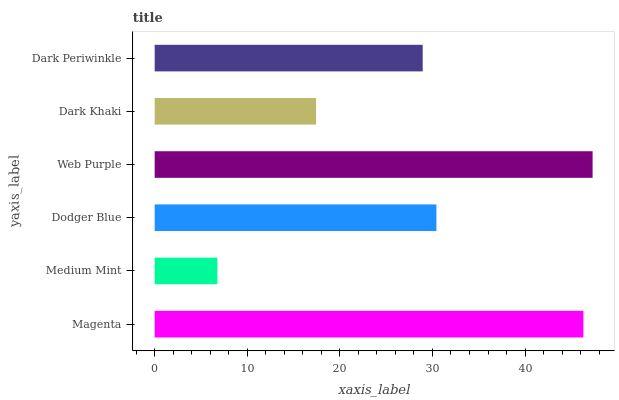Is Medium Mint the minimum?
Answer yes or no. Yes. Is Web Purple the maximum?
Answer yes or no. Yes. Is Dodger Blue the minimum?
Answer yes or no. No. Is Dodger Blue the maximum?
Answer yes or no. No. Is Dodger Blue greater than Medium Mint?
Answer yes or no. Yes. Is Medium Mint less than Dodger Blue?
Answer yes or no. Yes. Is Medium Mint greater than Dodger Blue?
Answer yes or no. No. Is Dodger Blue less than Medium Mint?
Answer yes or no. No. Is Dodger Blue the high median?
Answer yes or no. Yes. Is Dark Periwinkle the low median?
Answer yes or no. Yes. Is Magenta the high median?
Answer yes or no. No. Is Medium Mint the low median?
Answer yes or no. No. 